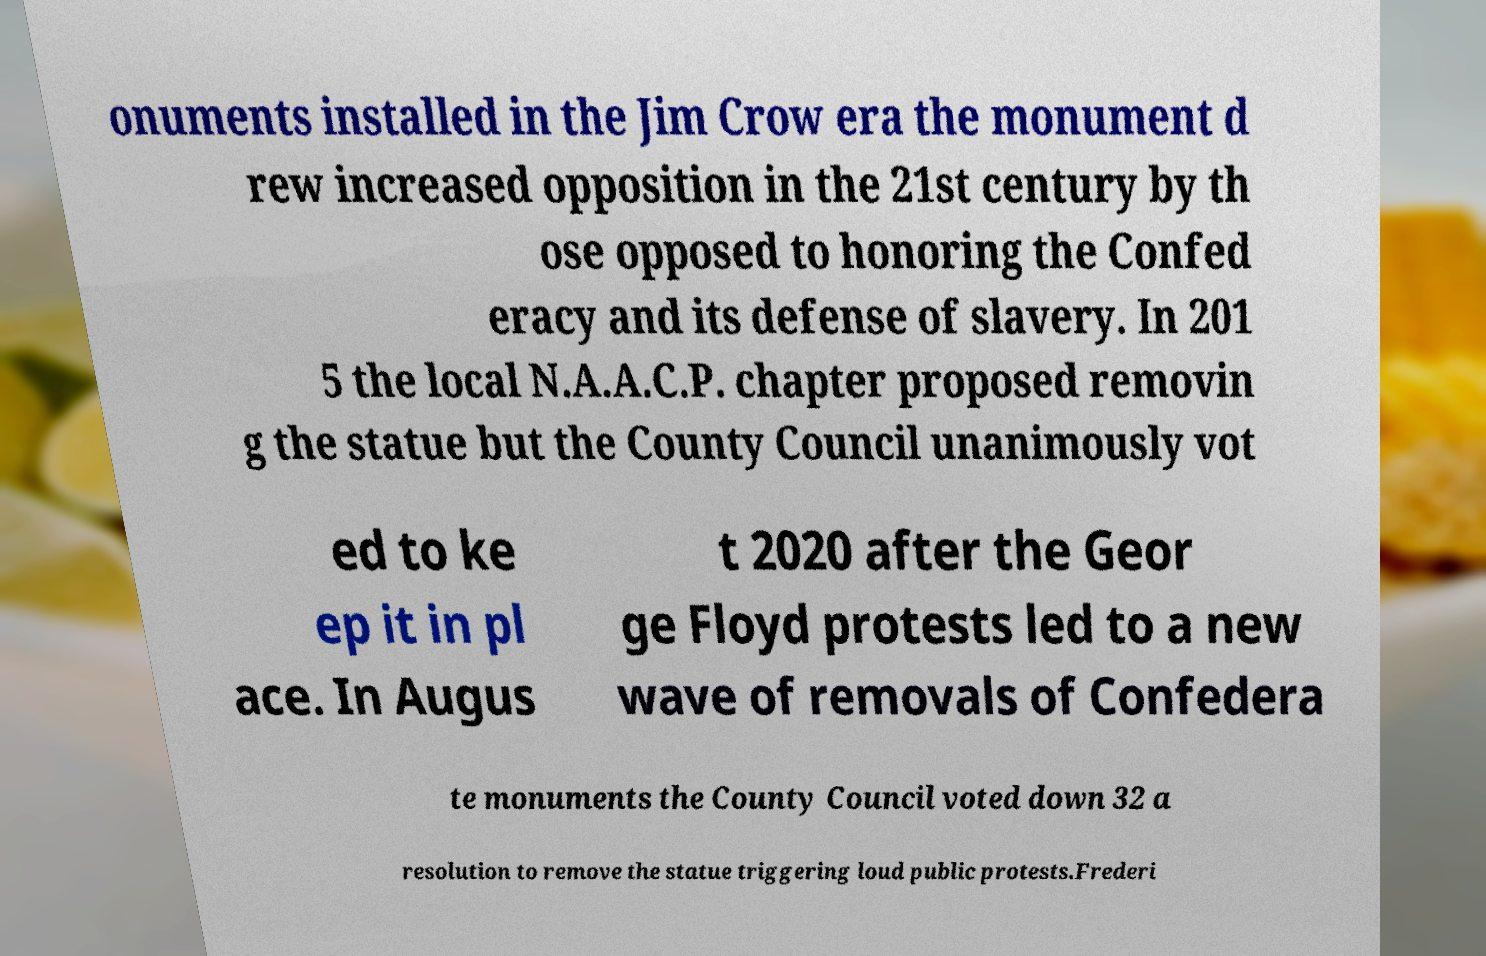Can you accurately transcribe the text from the provided image for me? onuments installed in the Jim Crow era the monument d rew increased opposition in the 21st century by th ose opposed to honoring the Confed eracy and its defense of slavery. In 201 5 the local N.A.A.C.P. chapter proposed removin g the statue but the County Council unanimously vot ed to ke ep it in pl ace. In Augus t 2020 after the Geor ge Floyd protests led to a new wave of removals of Confedera te monuments the County Council voted down 32 a resolution to remove the statue triggering loud public protests.Frederi 